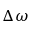Convert formula to latex. <formula><loc_0><loc_0><loc_500><loc_500>\Delta \omega</formula> 